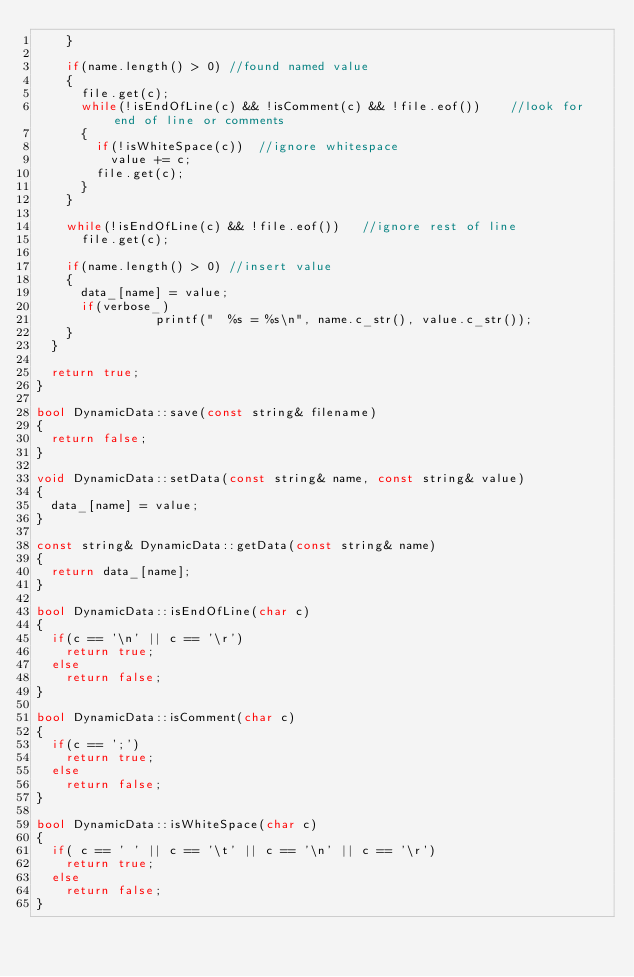Convert code to text. <code><loc_0><loc_0><loc_500><loc_500><_C++_>		}

		if(name.length() > 0)	//found named value
		{
			file.get(c);
			while(!isEndOfLine(c) && !isComment(c) && !file.eof())		//look for end of line or comments
			{
				if(!isWhiteSpace(c))	//ignore whitespace
					value += c;
				file.get(c);
			}
		}
		
		while(!isEndOfLine(c) && !file.eof())		//ignore rest of line
			file.get(c);
					
		if(name.length() > 0)	//insert value
		{
			data_[name] = value;
			if(verbose_)
                printf("  %s = %s\n", name.c_str(), value.c_str());
		}
	}

	return true;
}

bool DynamicData::save(const string& filename)
{
	return false;
}

void DynamicData::setData(const string& name, const string& value)
{
	data_[name] = value;
}

const string& DynamicData::getData(const string& name)
{
	return data_[name];
}

bool DynamicData::isEndOfLine(char c)
{
	if(c == '\n' || c == '\r')
		return true;
	else 
		return false;
}

bool DynamicData::isComment(char c)
{
	if(c == ';')
		return true;
	else
		return false;
}

bool DynamicData::isWhiteSpace(char c)
{
	if(	c == ' ' || c == '\t' || c == '\n' || c == '\r')
		return true;
	else
		return false;
}</code> 